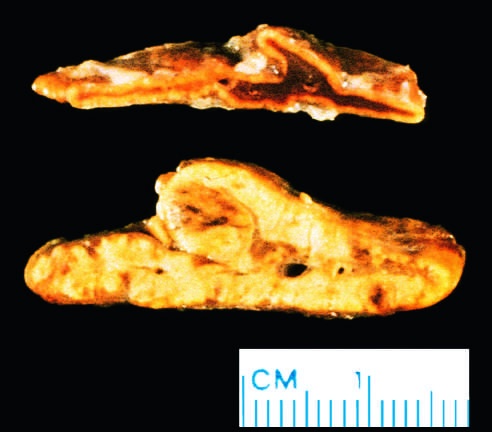s microscopic view of breast carcinoma yellow and thickened?
Answer the question using a single word or phrase. No 